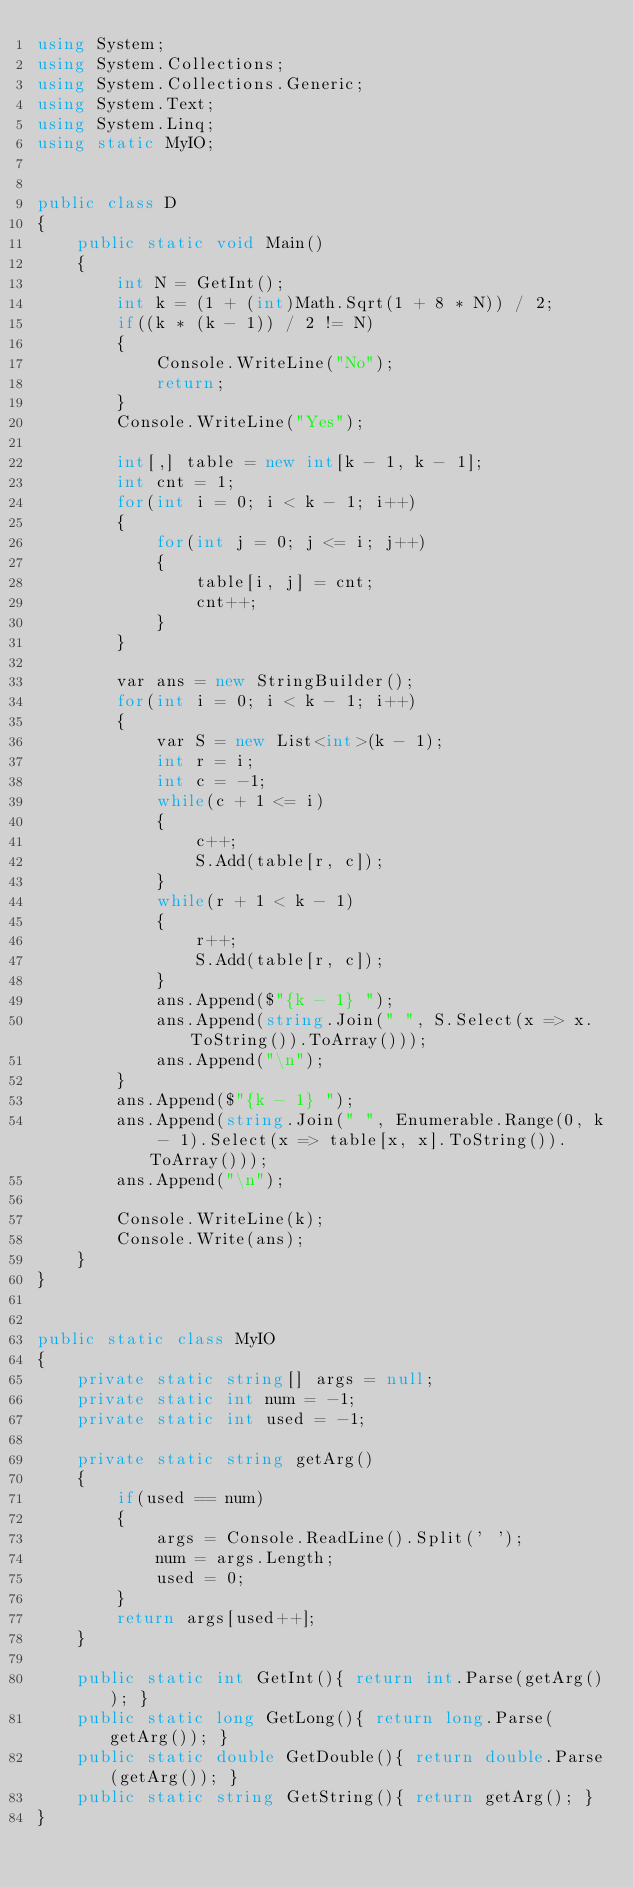Convert code to text. <code><loc_0><loc_0><loc_500><loc_500><_C#_>using System;
using System.Collections;
using System.Collections.Generic;
using System.Text;
using System.Linq;
using static MyIO;


public class D
{
	public static void Main()
	{
		int N = GetInt();
		int k = (1 + (int)Math.Sqrt(1 + 8 * N)) / 2;
		if((k * (k - 1)) / 2 != N)
		{
			Console.WriteLine("No");
			return;
		}
		Console.WriteLine("Yes");

		int[,] table = new int[k - 1, k - 1];
		int cnt = 1;
		for(int i = 0; i < k - 1; i++)
		{
			for(int j = 0; j <= i; j++)
			{
				table[i, j] = cnt;
				cnt++;
			}
		}

		var ans = new StringBuilder();
		for(int i = 0; i < k - 1; i++)
		{
			var S = new List<int>(k - 1);
			int r = i;
			int c = -1;
			while(c + 1 <= i)
			{
				c++;
				S.Add(table[r, c]);
			}
			while(r + 1 < k - 1)
			{
				r++;
				S.Add(table[r, c]);
			}
			ans.Append($"{k - 1} ");
			ans.Append(string.Join(" ", S.Select(x => x.ToString()).ToArray()));
			ans.Append("\n");
		}
		ans.Append($"{k - 1} ");
		ans.Append(string.Join(" ", Enumerable.Range(0, k - 1).Select(x => table[x, x].ToString()).ToArray()));
		ans.Append("\n");

		Console.WriteLine(k);
		Console.Write(ans);
	}
}


public static class MyIO
{
	private static string[] args = null;
	private static int num = -1;
	private static int used = -1;

	private static string getArg()
	{
		if(used == num)
		{
			args = Console.ReadLine().Split(' ');
			num = args.Length;
			used = 0;
		}
		return args[used++];
	}

	public static int GetInt(){ return int.Parse(getArg()); }
	public static long GetLong(){ return long.Parse(getArg()); }
	public static double GetDouble(){ return double.Parse(getArg()); }
	public static string GetString(){ return getArg(); }
}



</code> 